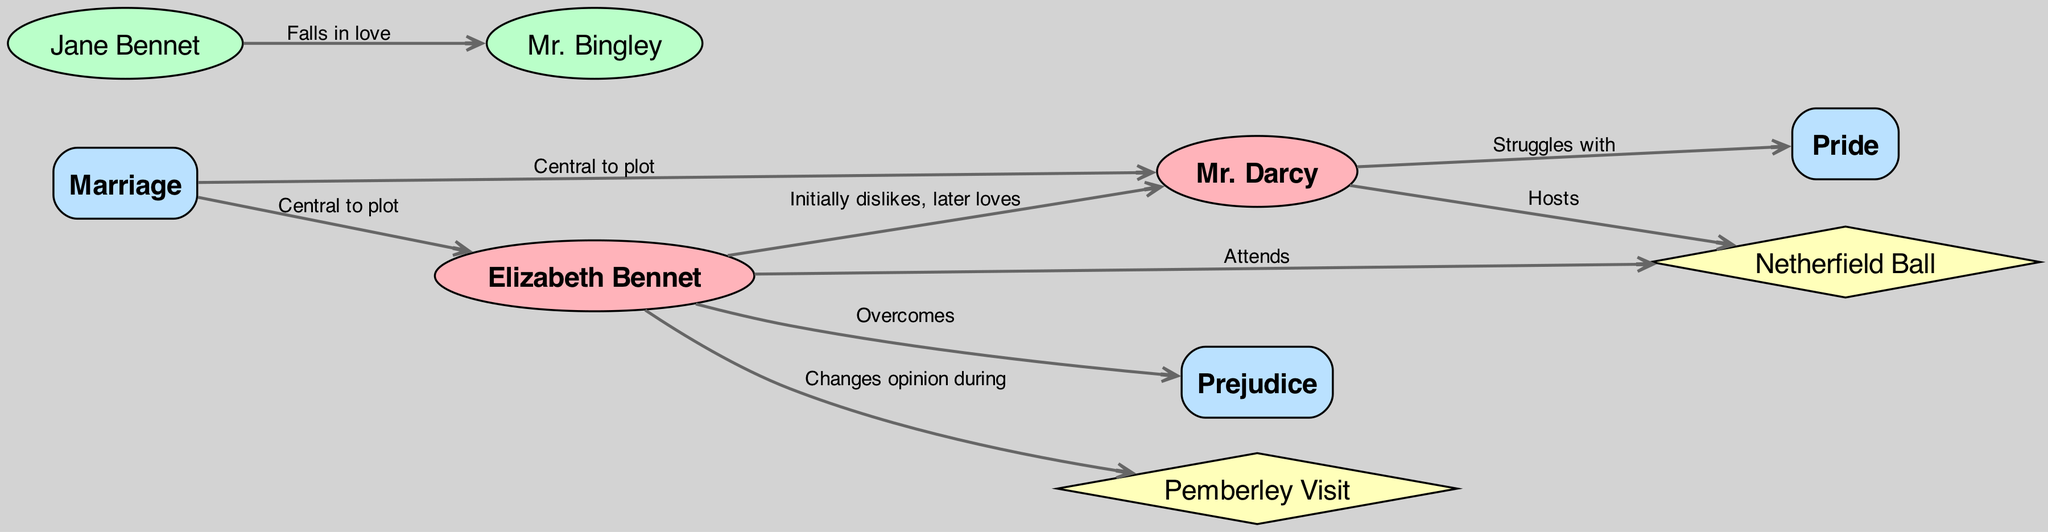What is the relationship between Elizabeth Bennet and Mr. Darcy? The edge connecting Elizabeth Bennet and Mr. Darcy is labeled "Initially dislikes, later loves," which indicates their evolving feelings towards each other throughout the plot.
Answer: Initially dislikes, later loves How many supporting characters are represented in the diagram? The diagram includes two nodes labeled as supporting characters: Jane Bennet and Mr. Bingley. Thus, counting these nodes gives us the total number of supporting characters.
Answer: 2 What theme is associated with Mr. Darcy? The edge connecting Mr. Darcy and the theme "Pride" shows that he struggles with this theme throughout the novel. Therefore, by referring to the edges in the diagram, we can identify the theme.
Answer: Pride Which plot event changes Elizabeth's opinion of Mr. Darcy? The edge labeled "Changes opinion during" connects Elizabeth Bennet to the Pemberley Visit, indicating that her opinion of Mr. Darcy shifts during this event.
Answer: Pemberley Visit What theme is central to both Elizabeth Bennet and Mr. Darcy? Both characters have edges connecting them to the theme "Marriage," signifying that this theme is pivotal in their story arcs. Thus, we can deduce that the central theme that links them is marriage.
Answer: Marriage Which character attends the Netherfield Ball? The diagram indicates that Elizabeth Bennet attends the event, as shown by the edge connecting her to the Netherfield Ball, which specifies her participation.
Answer: Elizabeth Bennet 